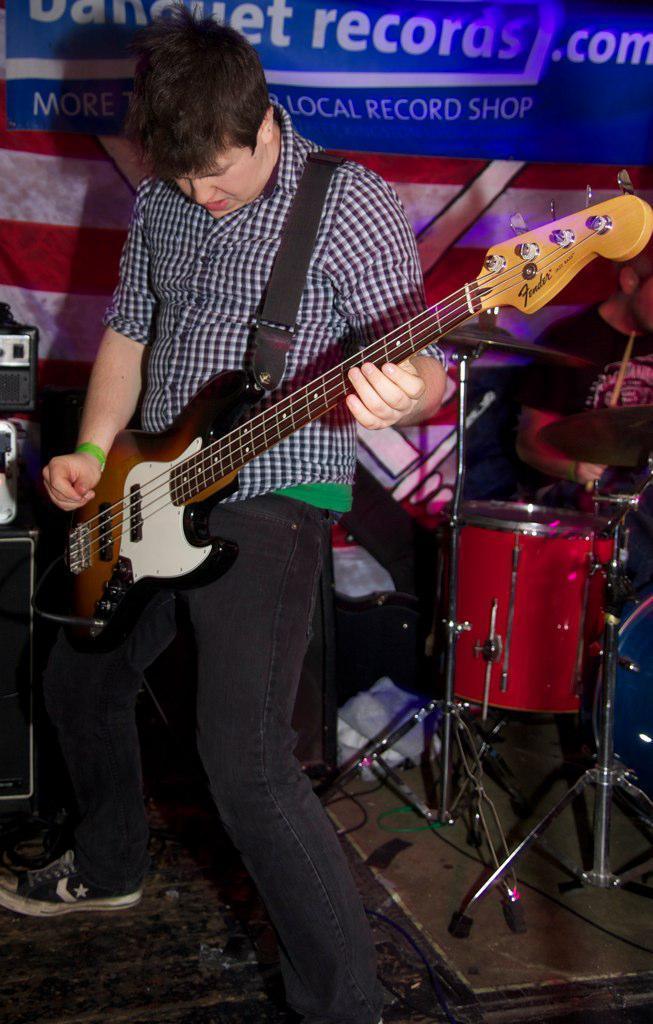Can you describe this image briefly? In this image in the middle there is a man he wears check shirt, trouser and shoes he is playing guitar. In the background there are drums, speaker and poster. 